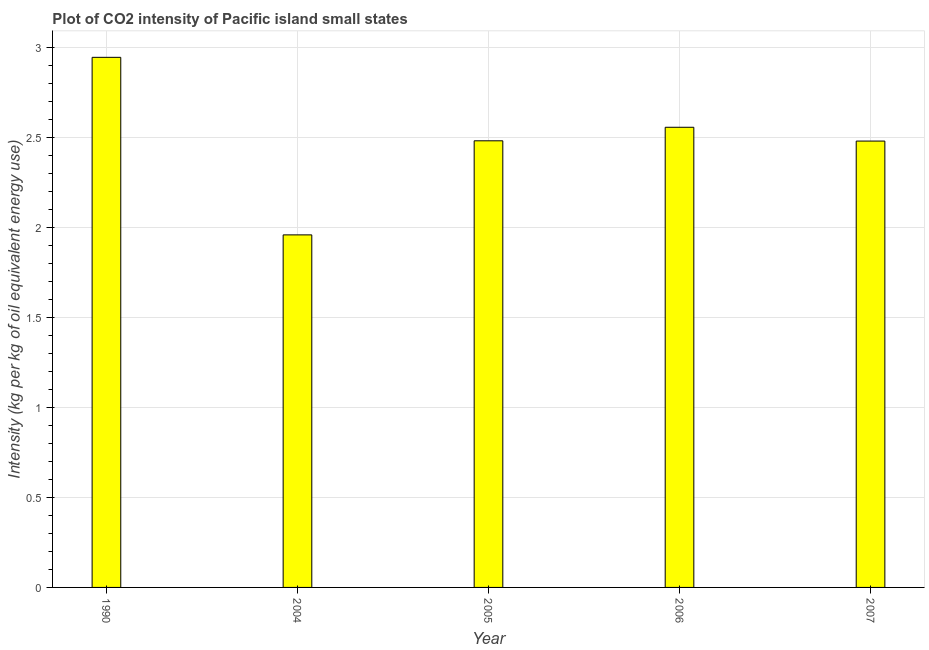Does the graph contain grids?
Offer a terse response. Yes. What is the title of the graph?
Offer a terse response. Plot of CO2 intensity of Pacific island small states. What is the label or title of the X-axis?
Your response must be concise. Year. What is the label or title of the Y-axis?
Provide a short and direct response. Intensity (kg per kg of oil equivalent energy use). What is the co2 intensity in 2005?
Offer a terse response. 2.48. Across all years, what is the maximum co2 intensity?
Your answer should be compact. 2.95. Across all years, what is the minimum co2 intensity?
Keep it short and to the point. 1.96. In which year was the co2 intensity maximum?
Give a very brief answer. 1990. In which year was the co2 intensity minimum?
Offer a very short reply. 2004. What is the sum of the co2 intensity?
Give a very brief answer. 12.43. What is the difference between the co2 intensity in 1990 and 2007?
Your answer should be compact. 0.47. What is the average co2 intensity per year?
Give a very brief answer. 2.48. What is the median co2 intensity?
Offer a terse response. 2.48. In how many years, is the co2 intensity greater than 1.5 kg?
Provide a short and direct response. 5. Do a majority of the years between 2006 and 2007 (inclusive) have co2 intensity greater than 2.6 kg?
Provide a short and direct response. No. What is the ratio of the co2 intensity in 1990 to that in 2005?
Offer a terse response. 1.19. Is the co2 intensity in 1990 less than that in 2005?
Ensure brevity in your answer.  No. Is the difference between the co2 intensity in 2004 and 2007 greater than the difference between any two years?
Make the answer very short. No. What is the difference between the highest and the second highest co2 intensity?
Keep it short and to the point. 0.39. Is the sum of the co2 intensity in 1990 and 2005 greater than the maximum co2 intensity across all years?
Offer a terse response. Yes. What is the difference between the highest and the lowest co2 intensity?
Provide a succinct answer. 0.99. How many bars are there?
Ensure brevity in your answer.  5. How many years are there in the graph?
Offer a terse response. 5. What is the difference between two consecutive major ticks on the Y-axis?
Your answer should be compact. 0.5. What is the Intensity (kg per kg of oil equivalent energy use) of 1990?
Make the answer very short. 2.95. What is the Intensity (kg per kg of oil equivalent energy use) in 2004?
Ensure brevity in your answer.  1.96. What is the Intensity (kg per kg of oil equivalent energy use) of 2005?
Your response must be concise. 2.48. What is the Intensity (kg per kg of oil equivalent energy use) of 2006?
Provide a short and direct response. 2.56. What is the Intensity (kg per kg of oil equivalent energy use) in 2007?
Offer a very short reply. 2.48. What is the difference between the Intensity (kg per kg of oil equivalent energy use) in 1990 and 2004?
Your answer should be compact. 0.99. What is the difference between the Intensity (kg per kg of oil equivalent energy use) in 1990 and 2005?
Give a very brief answer. 0.46. What is the difference between the Intensity (kg per kg of oil equivalent energy use) in 1990 and 2006?
Your answer should be very brief. 0.39. What is the difference between the Intensity (kg per kg of oil equivalent energy use) in 1990 and 2007?
Give a very brief answer. 0.47. What is the difference between the Intensity (kg per kg of oil equivalent energy use) in 2004 and 2005?
Provide a succinct answer. -0.52. What is the difference between the Intensity (kg per kg of oil equivalent energy use) in 2004 and 2006?
Give a very brief answer. -0.6. What is the difference between the Intensity (kg per kg of oil equivalent energy use) in 2004 and 2007?
Your answer should be compact. -0.52. What is the difference between the Intensity (kg per kg of oil equivalent energy use) in 2005 and 2006?
Your response must be concise. -0.08. What is the difference between the Intensity (kg per kg of oil equivalent energy use) in 2005 and 2007?
Make the answer very short. 0. What is the difference between the Intensity (kg per kg of oil equivalent energy use) in 2006 and 2007?
Give a very brief answer. 0.08. What is the ratio of the Intensity (kg per kg of oil equivalent energy use) in 1990 to that in 2004?
Give a very brief answer. 1.5. What is the ratio of the Intensity (kg per kg of oil equivalent energy use) in 1990 to that in 2005?
Your answer should be very brief. 1.19. What is the ratio of the Intensity (kg per kg of oil equivalent energy use) in 1990 to that in 2006?
Make the answer very short. 1.15. What is the ratio of the Intensity (kg per kg of oil equivalent energy use) in 1990 to that in 2007?
Ensure brevity in your answer.  1.19. What is the ratio of the Intensity (kg per kg of oil equivalent energy use) in 2004 to that in 2005?
Your answer should be compact. 0.79. What is the ratio of the Intensity (kg per kg of oil equivalent energy use) in 2004 to that in 2006?
Your response must be concise. 0.77. What is the ratio of the Intensity (kg per kg of oil equivalent energy use) in 2004 to that in 2007?
Give a very brief answer. 0.79. What is the ratio of the Intensity (kg per kg of oil equivalent energy use) in 2005 to that in 2006?
Your answer should be very brief. 0.97. What is the ratio of the Intensity (kg per kg of oil equivalent energy use) in 2005 to that in 2007?
Keep it short and to the point. 1. What is the ratio of the Intensity (kg per kg of oil equivalent energy use) in 2006 to that in 2007?
Give a very brief answer. 1.03. 